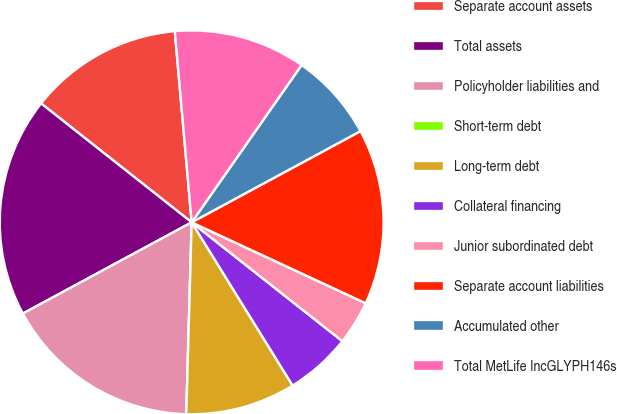<chart> <loc_0><loc_0><loc_500><loc_500><pie_chart><fcel>Separate account assets<fcel>Total assets<fcel>Policyholder liabilities and<fcel>Short-term debt<fcel>Long-term debt<fcel>Collateral financing<fcel>Junior subordinated debt<fcel>Separate account liabilities<fcel>Accumulated other<fcel>Total MetLife IncGLYPH146s<nl><fcel>12.96%<fcel>18.52%<fcel>16.67%<fcel>0.0%<fcel>9.26%<fcel>5.56%<fcel>3.7%<fcel>14.81%<fcel>7.41%<fcel>11.11%<nl></chart> 